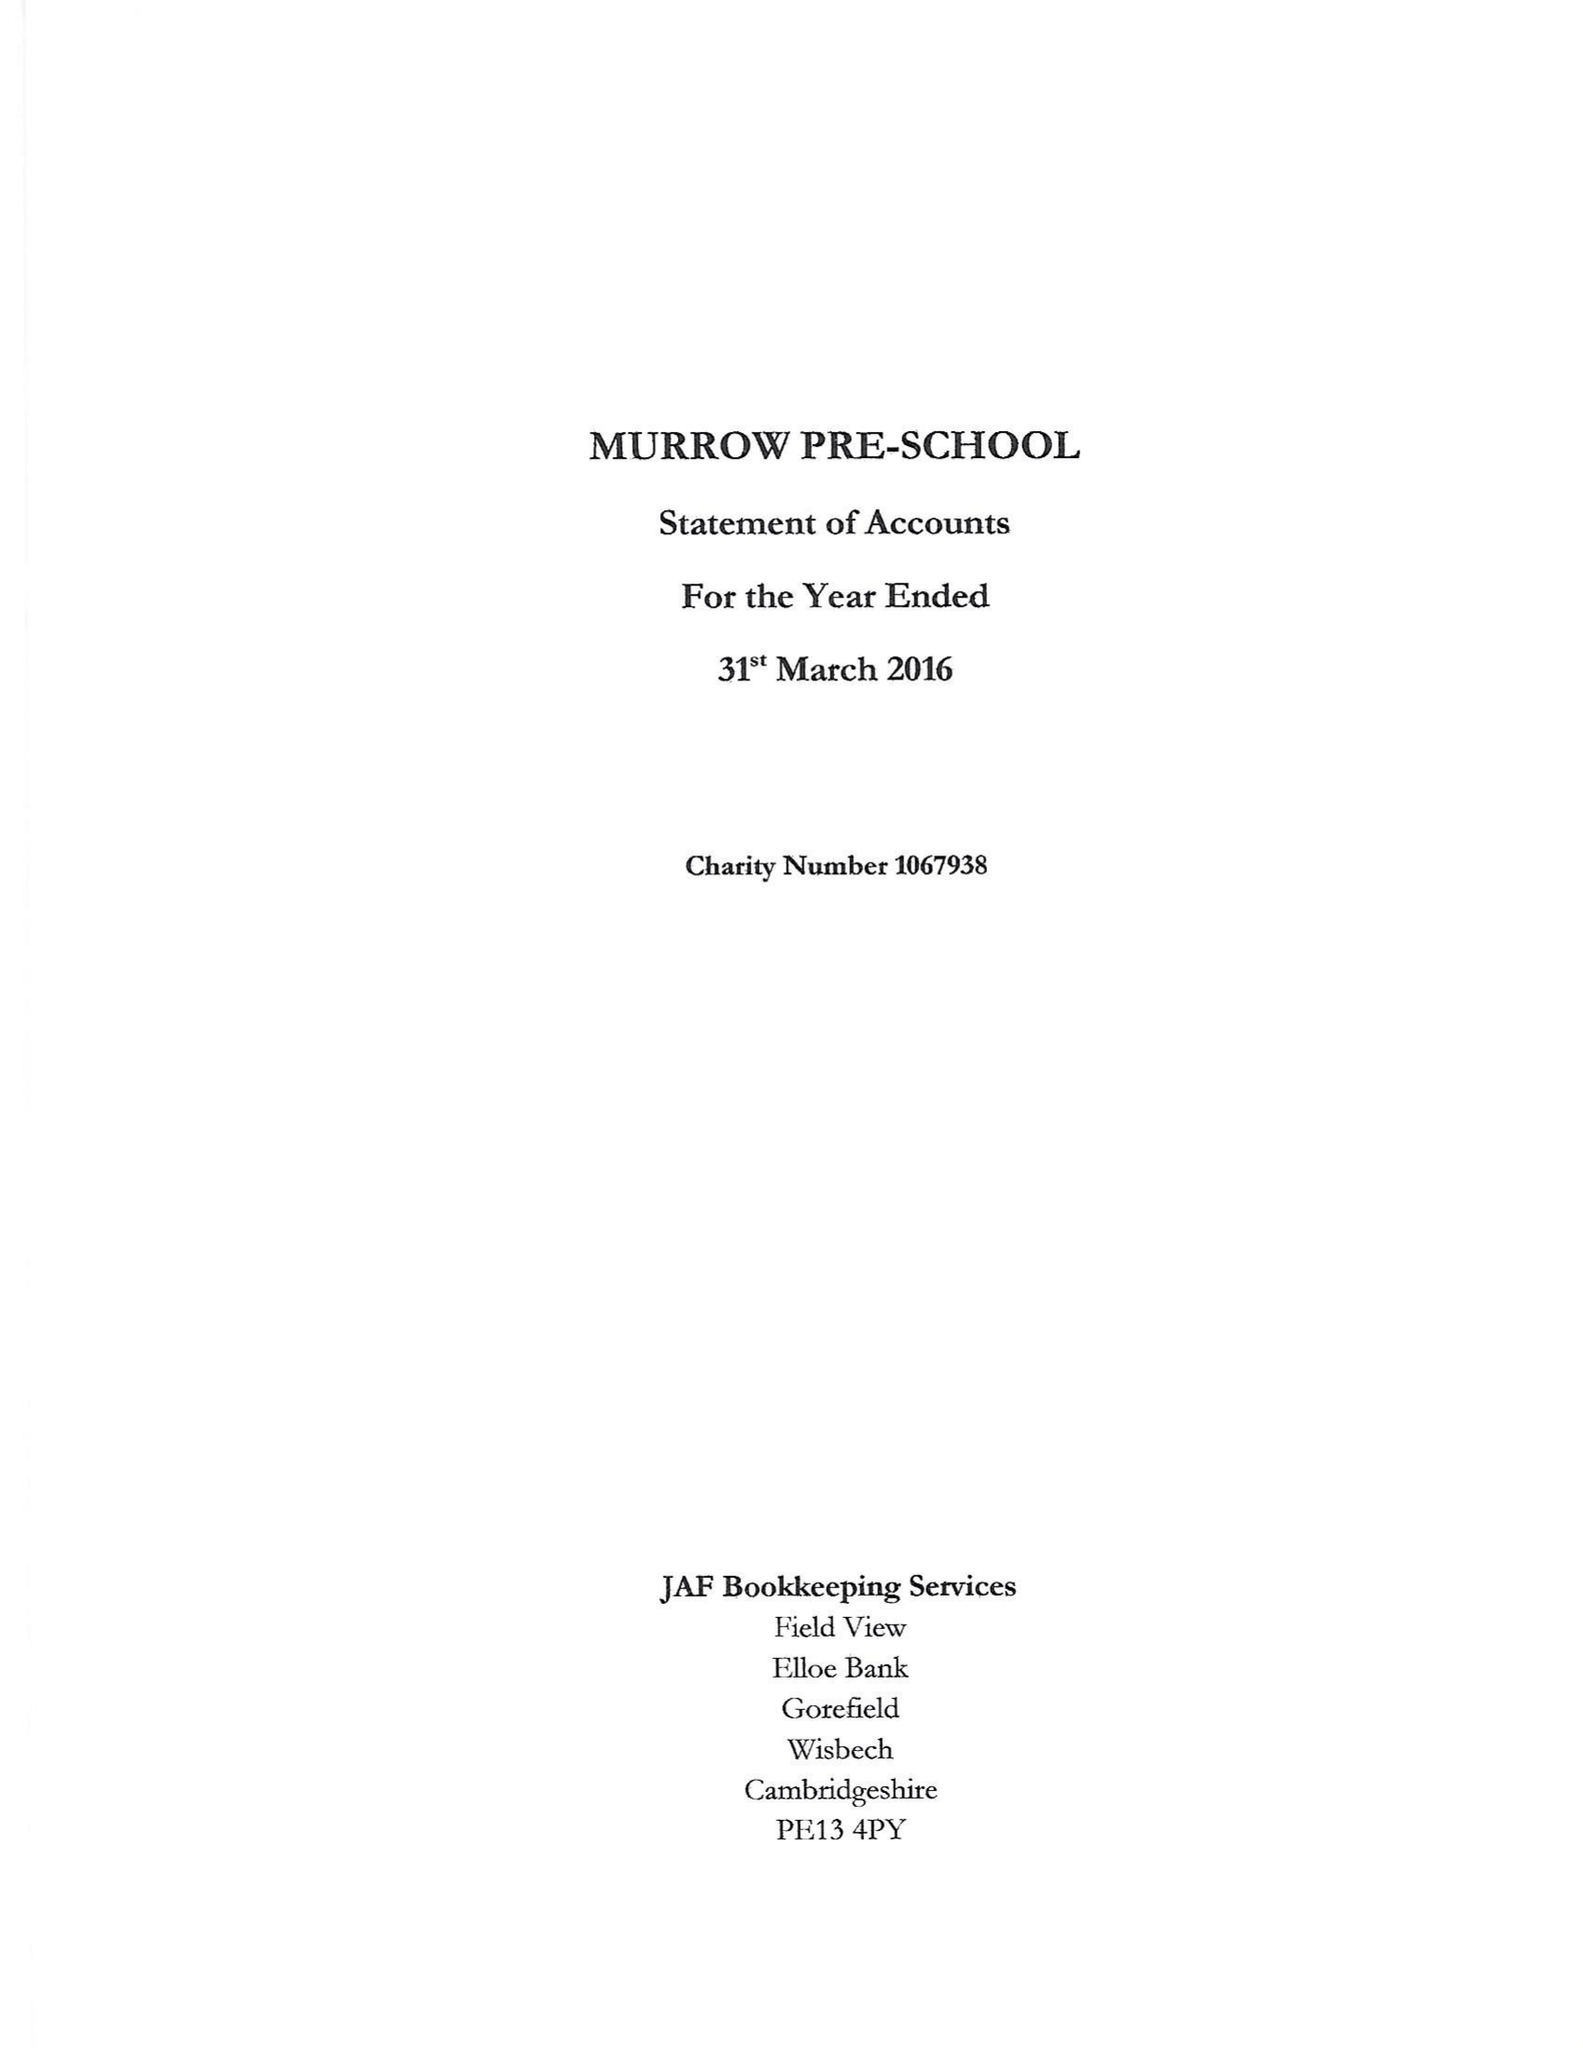What is the value for the charity_name?
Answer the question using a single word or phrase. Murrow Pre - School 